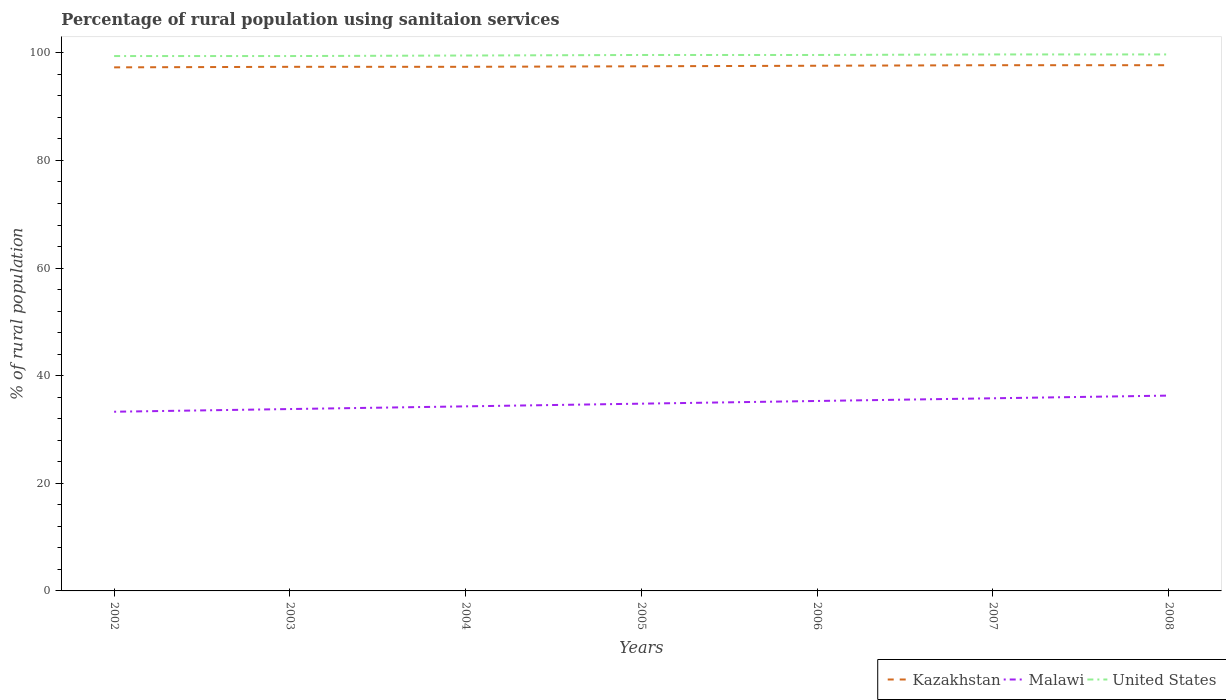Does the line corresponding to United States intersect with the line corresponding to Malawi?
Your answer should be very brief. No. Across all years, what is the maximum percentage of rural population using sanitaion services in Malawi?
Offer a very short reply. 33.3. In which year was the percentage of rural population using sanitaion services in United States maximum?
Your response must be concise. 2002. What is the difference between the highest and the second highest percentage of rural population using sanitaion services in United States?
Provide a succinct answer. 0.3. How many lines are there?
Your answer should be compact. 3. What is the difference between two consecutive major ticks on the Y-axis?
Provide a short and direct response. 20. Does the graph contain any zero values?
Offer a very short reply. No. How many legend labels are there?
Keep it short and to the point. 3. What is the title of the graph?
Provide a succinct answer. Percentage of rural population using sanitaion services. What is the label or title of the X-axis?
Your answer should be compact. Years. What is the label or title of the Y-axis?
Ensure brevity in your answer.  % of rural population. What is the % of rural population of Kazakhstan in 2002?
Your response must be concise. 97.3. What is the % of rural population in Malawi in 2002?
Your answer should be very brief. 33.3. What is the % of rural population in United States in 2002?
Offer a terse response. 99.4. What is the % of rural population in Kazakhstan in 2003?
Provide a short and direct response. 97.4. What is the % of rural population of Malawi in 2003?
Your response must be concise. 33.8. What is the % of rural population in United States in 2003?
Keep it short and to the point. 99.4. What is the % of rural population of Kazakhstan in 2004?
Keep it short and to the point. 97.4. What is the % of rural population in Malawi in 2004?
Your answer should be compact. 34.3. What is the % of rural population in United States in 2004?
Your answer should be very brief. 99.5. What is the % of rural population of Kazakhstan in 2005?
Ensure brevity in your answer.  97.5. What is the % of rural population in Malawi in 2005?
Offer a very short reply. 34.8. What is the % of rural population of United States in 2005?
Your answer should be compact. 99.6. What is the % of rural population in Kazakhstan in 2006?
Your answer should be very brief. 97.6. What is the % of rural population in Malawi in 2006?
Provide a short and direct response. 35.3. What is the % of rural population of United States in 2006?
Your response must be concise. 99.6. What is the % of rural population in Kazakhstan in 2007?
Give a very brief answer. 97.7. What is the % of rural population in Malawi in 2007?
Keep it short and to the point. 35.8. What is the % of rural population of United States in 2007?
Keep it short and to the point. 99.7. What is the % of rural population in Kazakhstan in 2008?
Your answer should be very brief. 97.7. What is the % of rural population in Malawi in 2008?
Give a very brief answer. 36.3. What is the % of rural population in United States in 2008?
Make the answer very short. 99.7. Across all years, what is the maximum % of rural population in Kazakhstan?
Offer a very short reply. 97.7. Across all years, what is the maximum % of rural population in Malawi?
Provide a short and direct response. 36.3. Across all years, what is the maximum % of rural population of United States?
Keep it short and to the point. 99.7. Across all years, what is the minimum % of rural population of Kazakhstan?
Provide a succinct answer. 97.3. Across all years, what is the minimum % of rural population of Malawi?
Offer a terse response. 33.3. Across all years, what is the minimum % of rural population in United States?
Ensure brevity in your answer.  99.4. What is the total % of rural population of Kazakhstan in the graph?
Make the answer very short. 682.6. What is the total % of rural population in Malawi in the graph?
Offer a very short reply. 243.6. What is the total % of rural population in United States in the graph?
Provide a succinct answer. 696.9. What is the difference between the % of rural population in Malawi in 2002 and that in 2004?
Offer a very short reply. -1. What is the difference between the % of rural population of Kazakhstan in 2002 and that in 2005?
Keep it short and to the point. -0.2. What is the difference between the % of rural population in Malawi in 2002 and that in 2005?
Provide a short and direct response. -1.5. What is the difference between the % of rural population in United States in 2002 and that in 2005?
Offer a terse response. -0.2. What is the difference between the % of rural population in Kazakhstan in 2002 and that in 2007?
Give a very brief answer. -0.4. What is the difference between the % of rural population in Malawi in 2002 and that in 2007?
Make the answer very short. -2.5. What is the difference between the % of rural population in United States in 2002 and that in 2007?
Offer a very short reply. -0.3. What is the difference between the % of rural population in Kazakhstan in 2002 and that in 2008?
Provide a succinct answer. -0.4. What is the difference between the % of rural population in Malawi in 2002 and that in 2008?
Offer a very short reply. -3. What is the difference between the % of rural population in United States in 2002 and that in 2008?
Give a very brief answer. -0.3. What is the difference between the % of rural population in Kazakhstan in 2003 and that in 2004?
Provide a short and direct response. 0. What is the difference between the % of rural population in Malawi in 2003 and that in 2004?
Offer a terse response. -0.5. What is the difference between the % of rural population in United States in 2003 and that in 2004?
Offer a very short reply. -0.1. What is the difference between the % of rural population in Malawi in 2003 and that in 2005?
Make the answer very short. -1. What is the difference between the % of rural population of United States in 2003 and that in 2005?
Provide a succinct answer. -0.2. What is the difference between the % of rural population of United States in 2003 and that in 2006?
Offer a very short reply. -0.2. What is the difference between the % of rural population in Kazakhstan in 2003 and that in 2007?
Your answer should be very brief. -0.3. What is the difference between the % of rural population of United States in 2003 and that in 2007?
Your answer should be very brief. -0.3. What is the difference between the % of rural population in Malawi in 2003 and that in 2008?
Ensure brevity in your answer.  -2.5. What is the difference between the % of rural population in United States in 2003 and that in 2008?
Offer a very short reply. -0.3. What is the difference between the % of rural population of Malawi in 2004 and that in 2005?
Give a very brief answer. -0.5. What is the difference between the % of rural population in United States in 2004 and that in 2006?
Offer a very short reply. -0.1. What is the difference between the % of rural population of Kazakhstan in 2004 and that in 2007?
Make the answer very short. -0.3. What is the difference between the % of rural population of Malawi in 2004 and that in 2008?
Provide a short and direct response. -2. What is the difference between the % of rural population in Malawi in 2005 and that in 2006?
Your response must be concise. -0.5. What is the difference between the % of rural population of United States in 2005 and that in 2006?
Offer a terse response. 0. What is the difference between the % of rural population of Malawi in 2005 and that in 2007?
Make the answer very short. -1. What is the difference between the % of rural population in Kazakhstan in 2005 and that in 2008?
Provide a short and direct response. -0.2. What is the difference between the % of rural population in Malawi in 2005 and that in 2008?
Your response must be concise. -1.5. What is the difference between the % of rural population of United States in 2005 and that in 2008?
Your answer should be compact. -0.1. What is the difference between the % of rural population in Kazakhstan in 2006 and that in 2007?
Ensure brevity in your answer.  -0.1. What is the difference between the % of rural population of United States in 2007 and that in 2008?
Give a very brief answer. 0. What is the difference between the % of rural population of Kazakhstan in 2002 and the % of rural population of Malawi in 2003?
Your answer should be compact. 63.5. What is the difference between the % of rural population in Kazakhstan in 2002 and the % of rural population in United States in 2003?
Offer a terse response. -2.1. What is the difference between the % of rural population of Malawi in 2002 and the % of rural population of United States in 2003?
Offer a terse response. -66.1. What is the difference between the % of rural population in Kazakhstan in 2002 and the % of rural population in United States in 2004?
Your response must be concise. -2.2. What is the difference between the % of rural population of Malawi in 2002 and the % of rural population of United States in 2004?
Your answer should be very brief. -66.2. What is the difference between the % of rural population of Kazakhstan in 2002 and the % of rural population of Malawi in 2005?
Ensure brevity in your answer.  62.5. What is the difference between the % of rural population in Malawi in 2002 and the % of rural population in United States in 2005?
Your response must be concise. -66.3. What is the difference between the % of rural population in Malawi in 2002 and the % of rural population in United States in 2006?
Give a very brief answer. -66.3. What is the difference between the % of rural population of Kazakhstan in 2002 and the % of rural population of Malawi in 2007?
Give a very brief answer. 61.5. What is the difference between the % of rural population of Kazakhstan in 2002 and the % of rural population of United States in 2007?
Provide a succinct answer. -2.4. What is the difference between the % of rural population of Malawi in 2002 and the % of rural population of United States in 2007?
Give a very brief answer. -66.4. What is the difference between the % of rural population of Kazakhstan in 2002 and the % of rural population of United States in 2008?
Provide a succinct answer. -2.4. What is the difference between the % of rural population in Malawi in 2002 and the % of rural population in United States in 2008?
Provide a short and direct response. -66.4. What is the difference between the % of rural population of Kazakhstan in 2003 and the % of rural population of Malawi in 2004?
Your answer should be very brief. 63.1. What is the difference between the % of rural population in Malawi in 2003 and the % of rural population in United States in 2004?
Your response must be concise. -65.7. What is the difference between the % of rural population of Kazakhstan in 2003 and the % of rural population of Malawi in 2005?
Your response must be concise. 62.6. What is the difference between the % of rural population of Kazakhstan in 2003 and the % of rural population of United States in 2005?
Provide a short and direct response. -2.2. What is the difference between the % of rural population in Malawi in 2003 and the % of rural population in United States in 2005?
Provide a short and direct response. -65.8. What is the difference between the % of rural population in Kazakhstan in 2003 and the % of rural population in Malawi in 2006?
Your answer should be compact. 62.1. What is the difference between the % of rural population of Kazakhstan in 2003 and the % of rural population of United States in 2006?
Ensure brevity in your answer.  -2.2. What is the difference between the % of rural population in Malawi in 2003 and the % of rural population in United States in 2006?
Your response must be concise. -65.8. What is the difference between the % of rural population of Kazakhstan in 2003 and the % of rural population of Malawi in 2007?
Keep it short and to the point. 61.6. What is the difference between the % of rural population of Kazakhstan in 2003 and the % of rural population of United States in 2007?
Ensure brevity in your answer.  -2.3. What is the difference between the % of rural population of Malawi in 2003 and the % of rural population of United States in 2007?
Give a very brief answer. -65.9. What is the difference between the % of rural population of Kazakhstan in 2003 and the % of rural population of Malawi in 2008?
Provide a short and direct response. 61.1. What is the difference between the % of rural population in Malawi in 2003 and the % of rural population in United States in 2008?
Keep it short and to the point. -65.9. What is the difference between the % of rural population in Kazakhstan in 2004 and the % of rural population in Malawi in 2005?
Keep it short and to the point. 62.6. What is the difference between the % of rural population in Kazakhstan in 2004 and the % of rural population in United States in 2005?
Offer a terse response. -2.2. What is the difference between the % of rural population in Malawi in 2004 and the % of rural population in United States in 2005?
Your response must be concise. -65.3. What is the difference between the % of rural population of Kazakhstan in 2004 and the % of rural population of Malawi in 2006?
Your answer should be very brief. 62.1. What is the difference between the % of rural population of Kazakhstan in 2004 and the % of rural population of United States in 2006?
Offer a terse response. -2.2. What is the difference between the % of rural population in Malawi in 2004 and the % of rural population in United States in 2006?
Your answer should be very brief. -65.3. What is the difference between the % of rural population of Kazakhstan in 2004 and the % of rural population of Malawi in 2007?
Give a very brief answer. 61.6. What is the difference between the % of rural population in Kazakhstan in 2004 and the % of rural population in United States in 2007?
Make the answer very short. -2.3. What is the difference between the % of rural population in Malawi in 2004 and the % of rural population in United States in 2007?
Give a very brief answer. -65.4. What is the difference between the % of rural population of Kazakhstan in 2004 and the % of rural population of Malawi in 2008?
Give a very brief answer. 61.1. What is the difference between the % of rural population in Kazakhstan in 2004 and the % of rural population in United States in 2008?
Ensure brevity in your answer.  -2.3. What is the difference between the % of rural population in Malawi in 2004 and the % of rural population in United States in 2008?
Offer a very short reply. -65.4. What is the difference between the % of rural population of Kazakhstan in 2005 and the % of rural population of Malawi in 2006?
Offer a very short reply. 62.2. What is the difference between the % of rural population in Malawi in 2005 and the % of rural population in United States in 2006?
Your answer should be compact. -64.8. What is the difference between the % of rural population in Kazakhstan in 2005 and the % of rural population in Malawi in 2007?
Offer a very short reply. 61.7. What is the difference between the % of rural population of Kazakhstan in 2005 and the % of rural population of United States in 2007?
Provide a succinct answer. -2.2. What is the difference between the % of rural population of Malawi in 2005 and the % of rural population of United States in 2007?
Provide a short and direct response. -64.9. What is the difference between the % of rural population in Kazakhstan in 2005 and the % of rural population in Malawi in 2008?
Provide a short and direct response. 61.2. What is the difference between the % of rural population of Malawi in 2005 and the % of rural population of United States in 2008?
Your response must be concise. -64.9. What is the difference between the % of rural population in Kazakhstan in 2006 and the % of rural population in Malawi in 2007?
Provide a short and direct response. 61.8. What is the difference between the % of rural population of Kazakhstan in 2006 and the % of rural population of United States in 2007?
Your answer should be very brief. -2.1. What is the difference between the % of rural population in Malawi in 2006 and the % of rural population in United States in 2007?
Provide a short and direct response. -64.4. What is the difference between the % of rural population of Kazakhstan in 2006 and the % of rural population of Malawi in 2008?
Provide a succinct answer. 61.3. What is the difference between the % of rural population of Kazakhstan in 2006 and the % of rural population of United States in 2008?
Your response must be concise. -2.1. What is the difference between the % of rural population in Malawi in 2006 and the % of rural population in United States in 2008?
Your answer should be very brief. -64.4. What is the difference between the % of rural population in Kazakhstan in 2007 and the % of rural population in Malawi in 2008?
Provide a succinct answer. 61.4. What is the difference between the % of rural population in Kazakhstan in 2007 and the % of rural population in United States in 2008?
Provide a short and direct response. -2. What is the difference between the % of rural population in Malawi in 2007 and the % of rural population in United States in 2008?
Provide a short and direct response. -63.9. What is the average % of rural population in Kazakhstan per year?
Offer a very short reply. 97.51. What is the average % of rural population in Malawi per year?
Your response must be concise. 34.8. What is the average % of rural population in United States per year?
Ensure brevity in your answer.  99.56. In the year 2002, what is the difference between the % of rural population in Kazakhstan and % of rural population in Malawi?
Your answer should be very brief. 64. In the year 2002, what is the difference between the % of rural population of Malawi and % of rural population of United States?
Make the answer very short. -66.1. In the year 2003, what is the difference between the % of rural population of Kazakhstan and % of rural population of Malawi?
Keep it short and to the point. 63.6. In the year 2003, what is the difference between the % of rural population of Malawi and % of rural population of United States?
Your response must be concise. -65.6. In the year 2004, what is the difference between the % of rural population of Kazakhstan and % of rural population of Malawi?
Make the answer very short. 63.1. In the year 2004, what is the difference between the % of rural population in Malawi and % of rural population in United States?
Keep it short and to the point. -65.2. In the year 2005, what is the difference between the % of rural population of Kazakhstan and % of rural population of Malawi?
Provide a short and direct response. 62.7. In the year 2005, what is the difference between the % of rural population in Kazakhstan and % of rural population in United States?
Ensure brevity in your answer.  -2.1. In the year 2005, what is the difference between the % of rural population of Malawi and % of rural population of United States?
Offer a terse response. -64.8. In the year 2006, what is the difference between the % of rural population in Kazakhstan and % of rural population in Malawi?
Offer a terse response. 62.3. In the year 2006, what is the difference between the % of rural population of Malawi and % of rural population of United States?
Offer a very short reply. -64.3. In the year 2007, what is the difference between the % of rural population of Kazakhstan and % of rural population of Malawi?
Your response must be concise. 61.9. In the year 2007, what is the difference between the % of rural population of Kazakhstan and % of rural population of United States?
Your answer should be very brief. -2. In the year 2007, what is the difference between the % of rural population in Malawi and % of rural population in United States?
Provide a succinct answer. -63.9. In the year 2008, what is the difference between the % of rural population in Kazakhstan and % of rural population in Malawi?
Keep it short and to the point. 61.4. In the year 2008, what is the difference between the % of rural population of Malawi and % of rural population of United States?
Keep it short and to the point. -63.4. What is the ratio of the % of rural population in Malawi in 2002 to that in 2003?
Make the answer very short. 0.99. What is the ratio of the % of rural population in Kazakhstan in 2002 to that in 2004?
Provide a succinct answer. 1. What is the ratio of the % of rural population in Malawi in 2002 to that in 2004?
Provide a short and direct response. 0.97. What is the ratio of the % of rural population of Kazakhstan in 2002 to that in 2005?
Make the answer very short. 1. What is the ratio of the % of rural population in Malawi in 2002 to that in 2005?
Provide a succinct answer. 0.96. What is the ratio of the % of rural population in Malawi in 2002 to that in 2006?
Make the answer very short. 0.94. What is the ratio of the % of rural population in United States in 2002 to that in 2006?
Provide a succinct answer. 1. What is the ratio of the % of rural population in Malawi in 2002 to that in 2007?
Offer a very short reply. 0.93. What is the ratio of the % of rural population of United States in 2002 to that in 2007?
Keep it short and to the point. 1. What is the ratio of the % of rural population of Kazakhstan in 2002 to that in 2008?
Make the answer very short. 1. What is the ratio of the % of rural population in Malawi in 2002 to that in 2008?
Your answer should be very brief. 0.92. What is the ratio of the % of rural population in Malawi in 2003 to that in 2004?
Provide a succinct answer. 0.99. What is the ratio of the % of rural population of Kazakhstan in 2003 to that in 2005?
Offer a very short reply. 1. What is the ratio of the % of rural population in Malawi in 2003 to that in 2005?
Offer a terse response. 0.97. What is the ratio of the % of rural population in Kazakhstan in 2003 to that in 2006?
Ensure brevity in your answer.  1. What is the ratio of the % of rural population of Malawi in 2003 to that in 2006?
Offer a terse response. 0.96. What is the ratio of the % of rural population in Malawi in 2003 to that in 2007?
Offer a very short reply. 0.94. What is the ratio of the % of rural population of Malawi in 2003 to that in 2008?
Keep it short and to the point. 0.93. What is the ratio of the % of rural population of Malawi in 2004 to that in 2005?
Offer a terse response. 0.99. What is the ratio of the % of rural population in United States in 2004 to that in 2005?
Give a very brief answer. 1. What is the ratio of the % of rural population of Kazakhstan in 2004 to that in 2006?
Your answer should be compact. 1. What is the ratio of the % of rural population of Malawi in 2004 to that in 2006?
Ensure brevity in your answer.  0.97. What is the ratio of the % of rural population of Kazakhstan in 2004 to that in 2007?
Your answer should be compact. 1. What is the ratio of the % of rural population of Malawi in 2004 to that in 2007?
Keep it short and to the point. 0.96. What is the ratio of the % of rural population in Kazakhstan in 2004 to that in 2008?
Make the answer very short. 1. What is the ratio of the % of rural population of Malawi in 2004 to that in 2008?
Ensure brevity in your answer.  0.94. What is the ratio of the % of rural population of United States in 2004 to that in 2008?
Give a very brief answer. 1. What is the ratio of the % of rural population of Malawi in 2005 to that in 2006?
Offer a terse response. 0.99. What is the ratio of the % of rural population of Malawi in 2005 to that in 2007?
Ensure brevity in your answer.  0.97. What is the ratio of the % of rural population of Kazakhstan in 2005 to that in 2008?
Offer a very short reply. 1. What is the ratio of the % of rural population of Malawi in 2005 to that in 2008?
Provide a short and direct response. 0.96. What is the ratio of the % of rural population of United States in 2005 to that in 2008?
Your answer should be compact. 1. What is the ratio of the % of rural population of Kazakhstan in 2006 to that in 2007?
Keep it short and to the point. 1. What is the ratio of the % of rural population of Malawi in 2006 to that in 2008?
Ensure brevity in your answer.  0.97. What is the ratio of the % of rural population in United States in 2006 to that in 2008?
Offer a terse response. 1. What is the ratio of the % of rural population of Malawi in 2007 to that in 2008?
Offer a terse response. 0.99. What is the ratio of the % of rural population of United States in 2007 to that in 2008?
Your answer should be compact. 1. What is the difference between the highest and the second highest % of rural population of Kazakhstan?
Provide a succinct answer. 0. What is the difference between the highest and the second highest % of rural population of United States?
Offer a terse response. 0. What is the difference between the highest and the lowest % of rural population in Kazakhstan?
Your response must be concise. 0.4. What is the difference between the highest and the lowest % of rural population of Malawi?
Keep it short and to the point. 3. What is the difference between the highest and the lowest % of rural population in United States?
Ensure brevity in your answer.  0.3. 